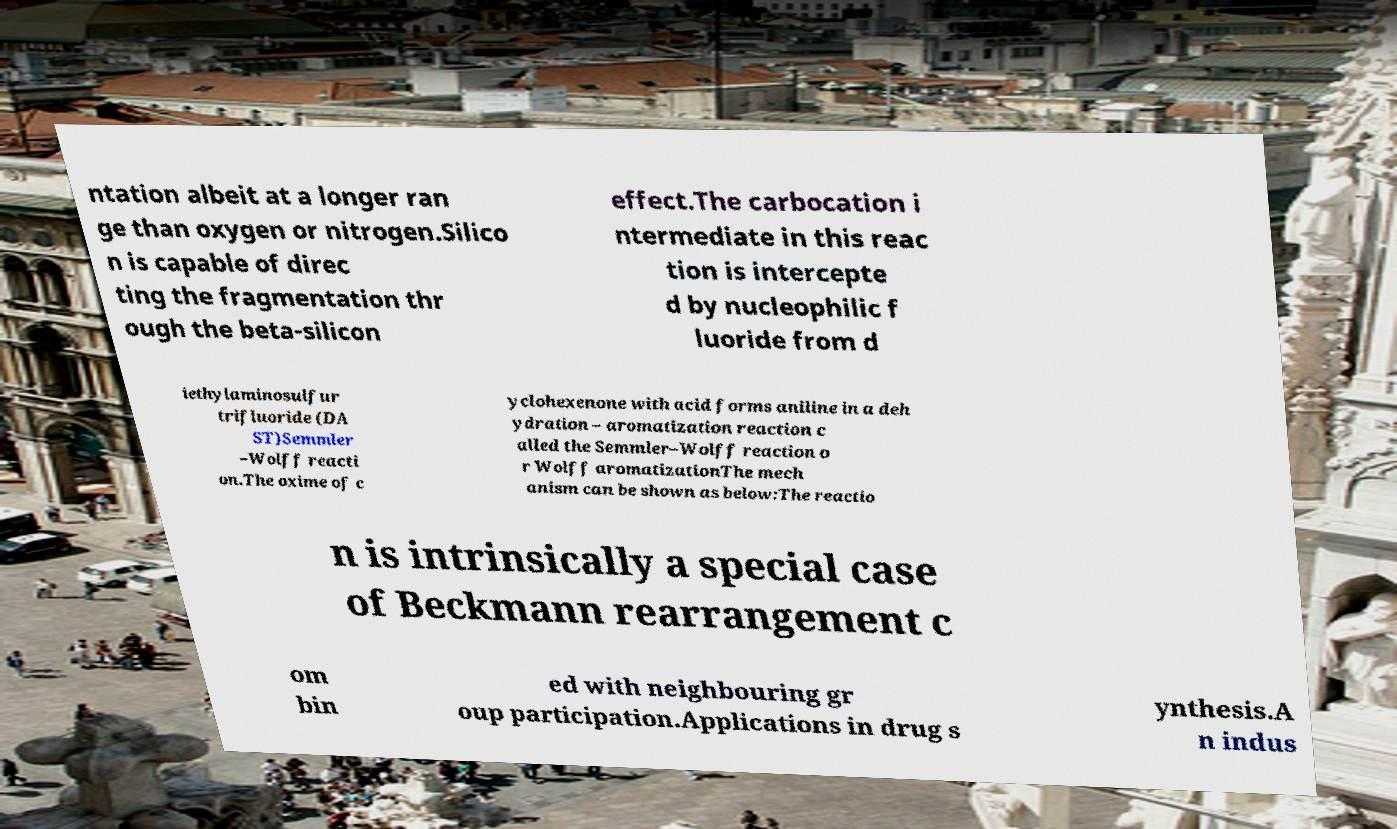There's text embedded in this image that I need extracted. Can you transcribe it verbatim? ntation albeit at a longer ran ge than oxygen or nitrogen.Silico n is capable of direc ting the fragmentation thr ough the beta-silicon effect.The carbocation i ntermediate in this reac tion is intercepte d by nucleophilic f luoride from d iethylaminosulfur trifluoride (DA ST)Semmler –Wolff reacti on.The oxime of c yclohexenone with acid forms aniline in a deh ydration – aromatization reaction c alled the Semmler–Wolff reaction o r Wolff aromatizationThe mech anism can be shown as below:The reactio n is intrinsically a special case of Beckmann rearrangement c om bin ed with neighbouring gr oup participation.Applications in drug s ynthesis.A n indus 